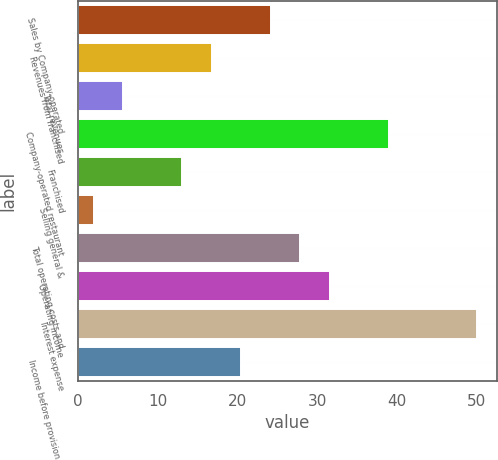Convert chart. <chart><loc_0><loc_0><loc_500><loc_500><bar_chart><fcel>Sales by Company-operated<fcel>Revenues from franchised<fcel>Total revenues<fcel>Company-operated restaurant<fcel>Franchised<fcel>Selling general &<fcel>Total operating costs and<fcel>Operating income<fcel>Interest expense<fcel>Income before provision for<nl><fcel>24.2<fcel>16.8<fcel>5.7<fcel>39<fcel>13.1<fcel>2<fcel>27.9<fcel>31.6<fcel>50.1<fcel>20.5<nl></chart> 